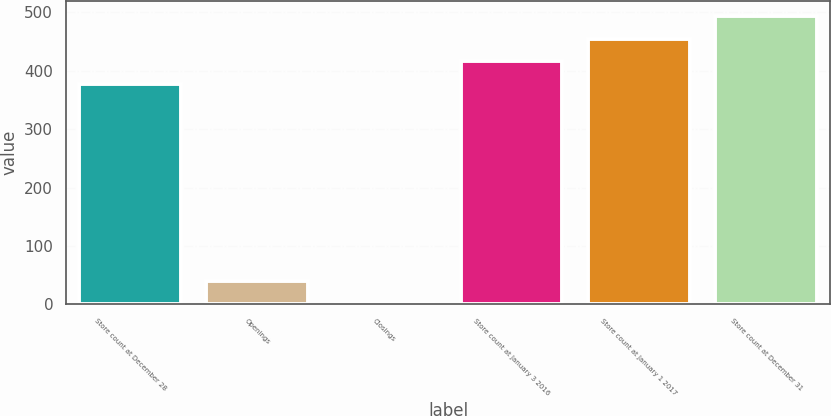Convert chart to OTSL. <chart><loc_0><loc_0><loc_500><loc_500><bar_chart><fcel>Store count at December 28<fcel>Openings<fcel>Closings<fcel>Store count at January 3 2016<fcel>Store count at January 1 2017<fcel>Store count at December 31<nl><fcel>377<fcel>40.1<fcel>1<fcel>416.1<fcel>455.2<fcel>494.3<nl></chart> 